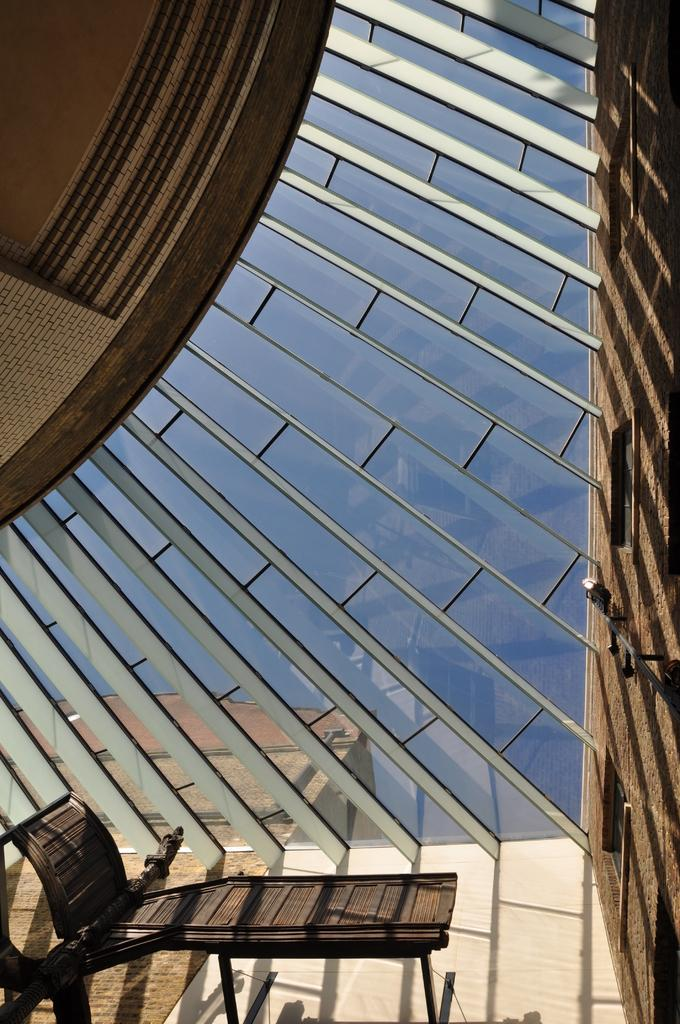What type of chair is in the image? There is a wooden chair in the image. What is the position of the chair in the image? The chair is laying on the floor. What material is the ceiling made of in the image? The ceiling in the image is made of glass. What can be seen on the right side of the image? There is a wall on the right side of the image. What type of operation is the brother performing on the step in the image? There is no brother, operation, or step present in the image. 